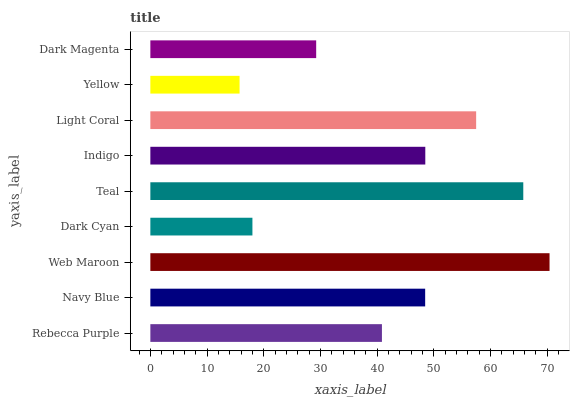Is Yellow the minimum?
Answer yes or no. Yes. Is Web Maroon the maximum?
Answer yes or no. Yes. Is Navy Blue the minimum?
Answer yes or no. No. Is Navy Blue the maximum?
Answer yes or no. No. Is Navy Blue greater than Rebecca Purple?
Answer yes or no. Yes. Is Rebecca Purple less than Navy Blue?
Answer yes or no. Yes. Is Rebecca Purple greater than Navy Blue?
Answer yes or no. No. Is Navy Blue less than Rebecca Purple?
Answer yes or no. No. Is Navy Blue the high median?
Answer yes or no. Yes. Is Navy Blue the low median?
Answer yes or no. Yes. Is Indigo the high median?
Answer yes or no. No. Is Rebecca Purple the low median?
Answer yes or no. No. 